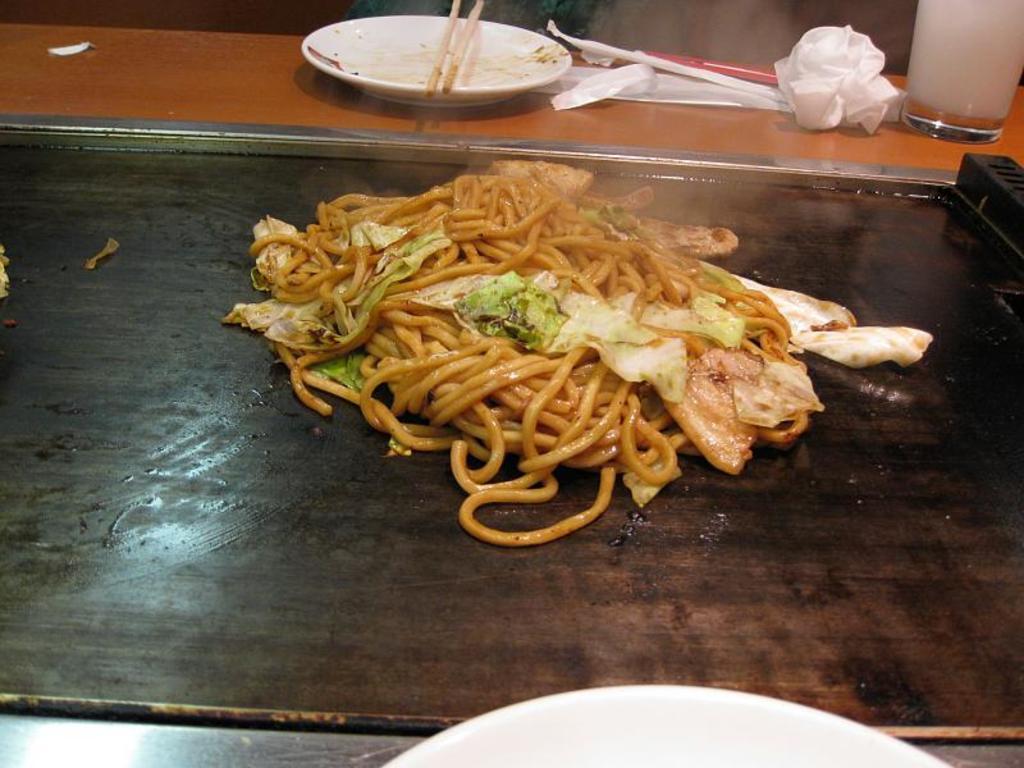How would you summarize this image in a sentence or two? In the center of the image there is a food item. On top of the table there are plates, tissues and a glass. 